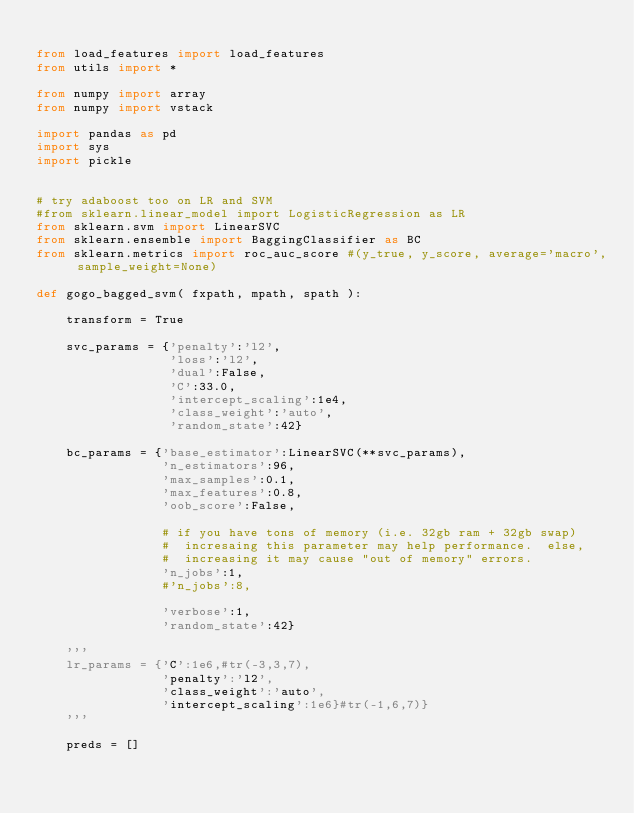Convert code to text. <code><loc_0><loc_0><loc_500><loc_500><_Python_>
from load_features import load_features
from utils import *

from numpy import array
from numpy import vstack

import pandas as pd
import sys
import pickle


# try adaboost too on LR and SVM
#from sklearn.linear_model import LogisticRegression as LR
from sklearn.svm import LinearSVC
from sklearn.ensemble import BaggingClassifier as BC
from sklearn.metrics import roc_auc_score #(y_true, y_score, average='macro', sample_weight=None)

def gogo_bagged_svm( fxpath, mpath, spath ):

    transform = True

    svc_params = {'penalty':'l2',
                  'loss':'l2', 
                  'dual':False,
                  'C':33.0, 
                  'intercept_scaling':1e4, 
                  'class_weight':'auto',
                  'random_state':42}

    bc_params = {'base_estimator':LinearSVC(**svc_params),
                 'n_estimators':96, 
                 'max_samples':0.1, 
                 'max_features':0.8,  
                 'oob_score':False,
                 
                 # if you have tons of memory (i.e. 32gb ram + 32gb swap)
                 #  incresaing this parameter may help performance.  else,
                 #  increasing it may cause "out of memory" errors.
                 'n_jobs':1,
                 #'n_jobs':8,

                 'verbose':1,
                 'random_state':42}

    '''
    lr_params = {'C':1e6,#tr(-3,3,7),
                 'penalty':'l2',
                 'class_weight':'auto',
                 'intercept_scaling':1e6}#tr(-1,6,7)}
    '''

    preds = []
</code> 